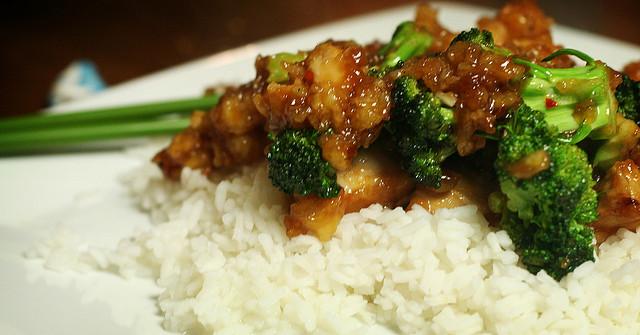What color is the rice?
Quick response, please. White. Are there any chopsticks on the plate?
Short answer required. Yes. What kind of dish is on the plate?
Short answer required. Chinese. What kind of ethnic food is on top of the rice?
Short answer required. Chinese. 